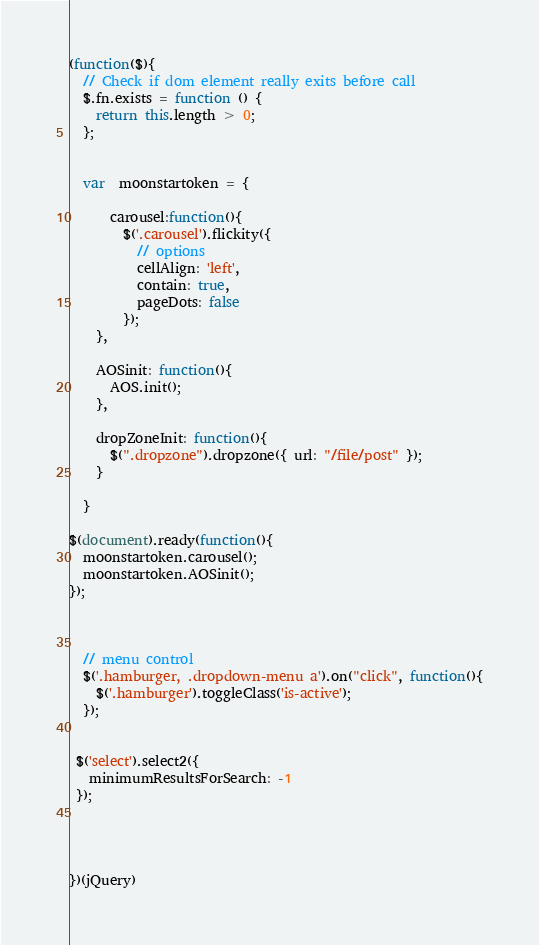Convert code to text. <code><loc_0><loc_0><loc_500><loc_500><_JavaScript_>(function($){
  // Check if dom element really exits before call
  $.fn.exists = function () {
    return this.length > 0;
  };


  var  moonstartoken = {

      carousel:function(){
        $('.carousel').flickity({
          // options
          cellAlign: 'left',
          contain: true,
          pageDots: false
        });
    },

    AOSinit: function(){
      AOS.init();
    }, 

    dropZoneInit: function(){
      $(".dropzone").dropzone({ url: "/file/post" });
    }
    
  }

$(document).ready(function(){
  moonstartoken.carousel();
  moonstartoken.AOSinit();
});



  // menu control 
  $('.hamburger, .dropdown-menu a').on("click", function(){
    $('.hamburger').toggleClass('is-active');
  }); 


 $('select').select2({
   minimumResultsForSearch: -1
 });




})(jQuery)</code> 